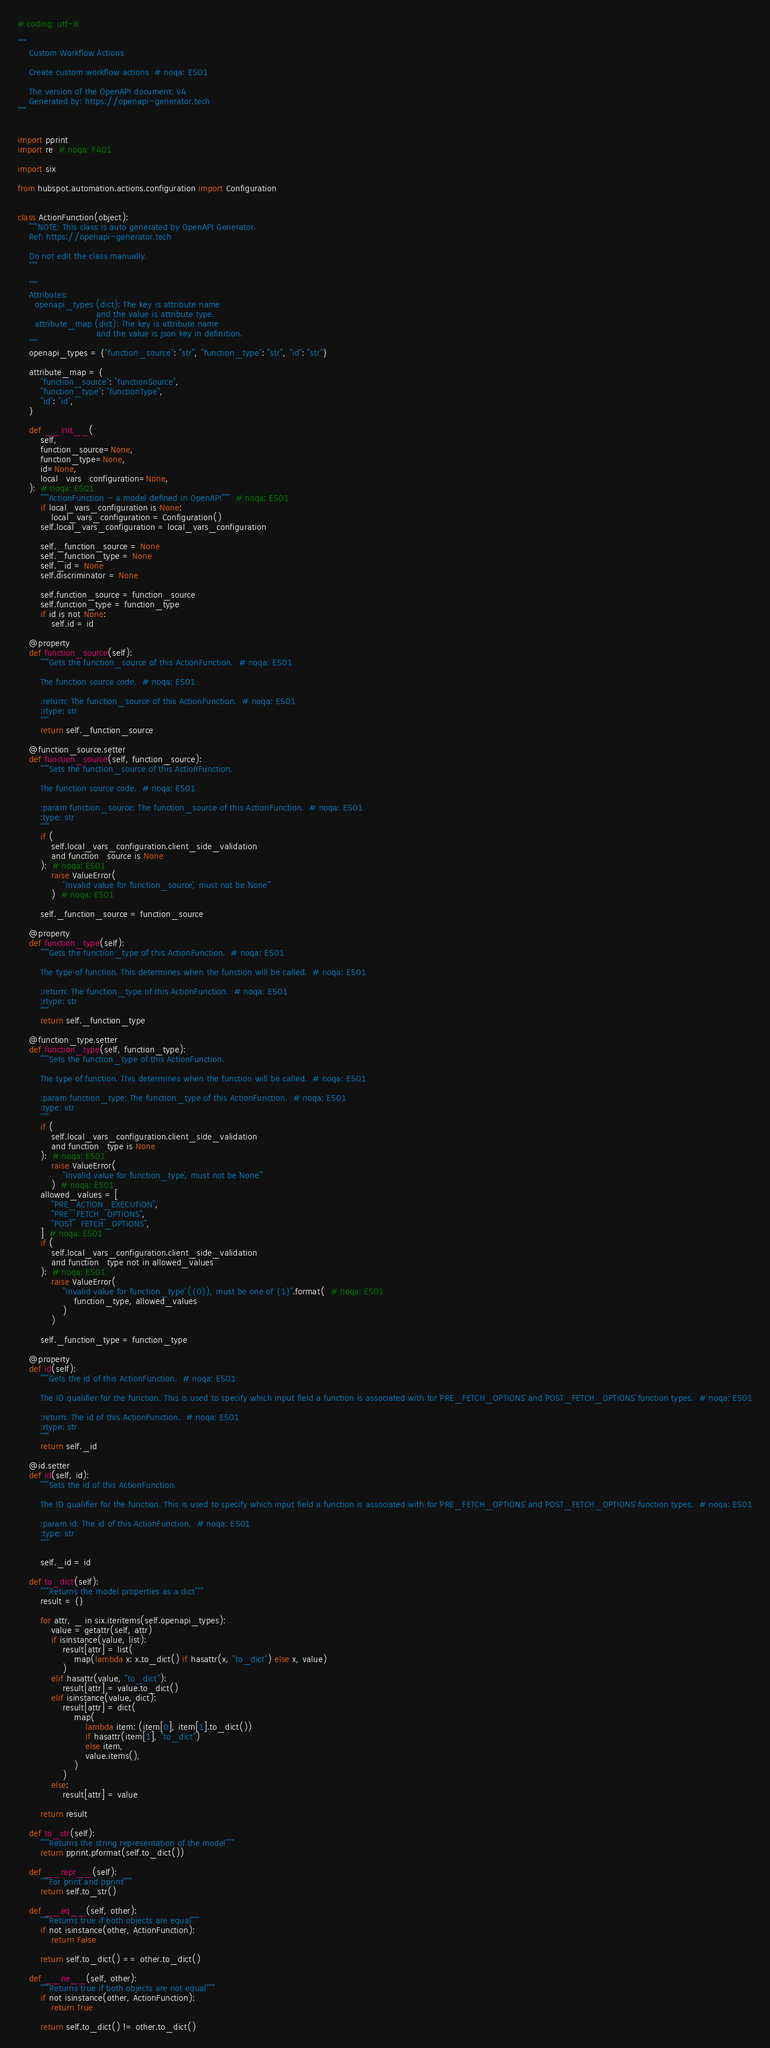<code> <loc_0><loc_0><loc_500><loc_500><_Python_># coding: utf-8

"""
    Custom Workflow Actions

    Create custom workflow actions  # noqa: E501

    The version of the OpenAPI document: v4
    Generated by: https://openapi-generator.tech
"""


import pprint
import re  # noqa: F401

import six

from hubspot.automation.actions.configuration import Configuration


class ActionFunction(object):
    """NOTE: This class is auto generated by OpenAPI Generator.
    Ref: https://openapi-generator.tech

    Do not edit the class manually.
    """

    """
    Attributes:
      openapi_types (dict): The key is attribute name
                            and the value is attribute type.
      attribute_map (dict): The key is attribute name
                            and the value is json key in definition.
    """
    openapi_types = {"function_source": "str", "function_type": "str", "id": "str"}

    attribute_map = {
        "function_source": "functionSource",
        "function_type": "functionType",
        "id": "id",
    }

    def __init__(
        self,
        function_source=None,
        function_type=None,
        id=None,
        local_vars_configuration=None,
    ):  # noqa: E501
        """ActionFunction - a model defined in OpenAPI"""  # noqa: E501
        if local_vars_configuration is None:
            local_vars_configuration = Configuration()
        self.local_vars_configuration = local_vars_configuration

        self._function_source = None
        self._function_type = None
        self._id = None
        self.discriminator = None

        self.function_source = function_source
        self.function_type = function_type
        if id is not None:
            self.id = id

    @property
    def function_source(self):
        """Gets the function_source of this ActionFunction.  # noqa: E501

        The function source code.  # noqa: E501

        :return: The function_source of this ActionFunction.  # noqa: E501
        :rtype: str
        """
        return self._function_source

    @function_source.setter
    def function_source(self, function_source):
        """Sets the function_source of this ActionFunction.

        The function source code.  # noqa: E501

        :param function_source: The function_source of this ActionFunction.  # noqa: E501
        :type: str
        """
        if (
            self.local_vars_configuration.client_side_validation
            and function_source is None
        ):  # noqa: E501
            raise ValueError(
                "Invalid value for `function_source`, must not be `None`"
            )  # noqa: E501

        self._function_source = function_source

    @property
    def function_type(self):
        """Gets the function_type of this ActionFunction.  # noqa: E501

        The type of function. This determines when the function will be called.  # noqa: E501

        :return: The function_type of this ActionFunction.  # noqa: E501
        :rtype: str
        """
        return self._function_type

    @function_type.setter
    def function_type(self, function_type):
        """Sets the function_type of this ActionFunction.

        The type of function. This determines when the function will be called.  # noqa: E501

        :param function_type: The function_type of this ActionFunction.  # noqa: E501
        :type: str
        """
        if (
            self.local_vars_configuration.client_side_validation
            and function_type is None
        ):  # noqa: E501
            raise ValueError(
                "Invalid value for `function_type`, must not be `None`"
            )  # noqa: E501
        allowed_values = [
            "PRE_ACTION_EXECUTION",
            "PRE_FETCH_OPTIONS",
            "POST_FETCH_OPTIONS",
        ]  # noqa: E501
        if (
            self.local_vars_configuration.client_side_validation
            and function_type not in allowed_values
        ):  # noqa: E501
            raise ValueError(
                "Invalid value for `function_type` ({0}), must be one of {1}".format(  # noqa: E501
                    function_type, allowed_values
                )
            )

        self._function_type = function_type

    @property
    def id(self):
        """Gets the id of this ActionFunction.  # noqa: E501

        The ID qualifier for the function. This is used to specify which input field a function is associated with for `PRE_FETCH_OPTIONS` and `POST_FETCH_OPTIONS` function types.  # noqa: E501

        :return: The id of this ActionFunction.  # noqa: E501
        :rtype: str
        """
        return self._id

    @id.setter
    def id(self, id):
        """Sets the id of this ActionFunction.

        The ID qualifier for the function. This is used to specify which input field a function is associated with for `PRE_FETCH_OPTIONS` and `POST_FETCH_OPTIONS` function types.  # noqa: E501

        :param id: The id of this ActionFunction.  # noqa: E501
        :type: str
        """

        self._id = id

    def to_dict(self):
        """Returns the model properties as a dict"""
        result = {}

        for attr, _ in six.iteritems(self.openapi_types):
            value = getattr(self, attr)
            if isinstance(value, list):
                result[attr] = list(
                    map(lambda x: x.to_dict() if hasattr(x, "to_dict") else x, value)
                )
            elif hasattr(value, "to_dict"):
                result[attr] = value.to_dict()
            elif isinstance(value, dict):
                result[attr] = dict(
                    map(
                        lambda item: (item[0], item[1].to_dict())
                        if hasattr(item[1], "to_dict")
                        else item,
                        value.items(),
                    )
                )
            else:
                result[attr] = value

        return result

    def to_str(self):
        """Returns the string representation of the model"""
        return pprint.pformat(self.to_dict())

    def __repr__(self):
        """For `print` and `pprint`"""
        return self.to_str()

    def __eq__(self, other):
        """Returns true if both objects are equal"""
        if not isinstance(other, ActionFunction):
            return False

        return self.to_dict() == other.to_dict()

    def __ne__(self, other):
        """Returns true if both objects are not equal"""
        if not isinstance(other, ActionFunction):
            return True

        return self.to_dict() != other.to_dict()
</code> 